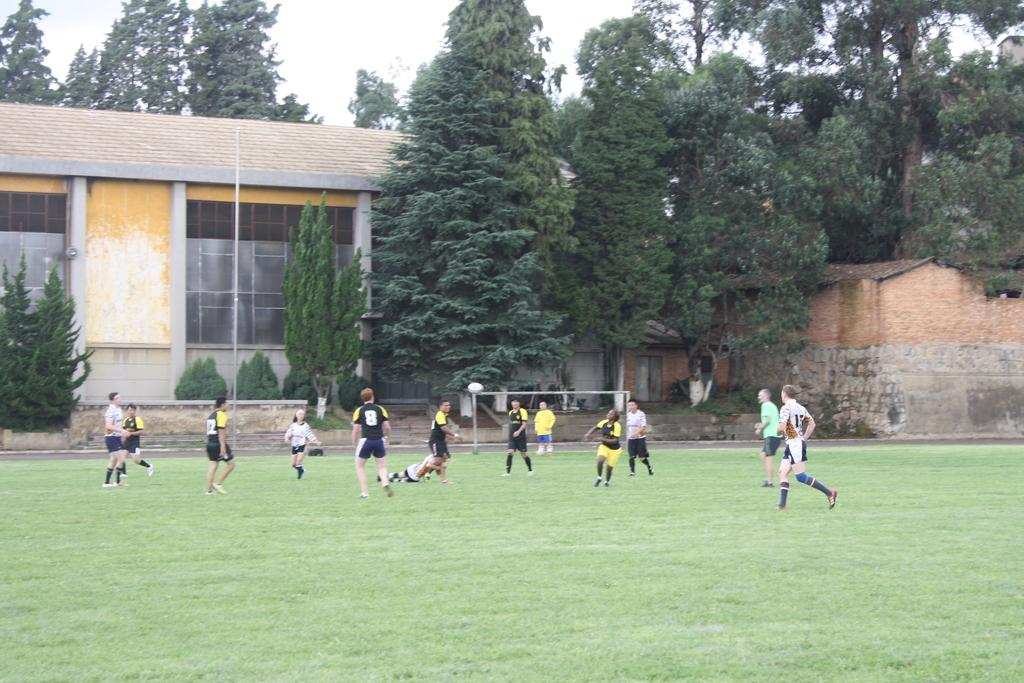What is the setting of the image? The image has an outside view. Who or what can be seen in the foreground? There are persons in the foreground. What are the persons wearing? The persons are wearing clothes. What activity are the persons engaged in? The persons are playing football. What can be seen in the background of the image? There is a building and trees in the background. What type of industry can be seen in the image? There is no industry present in the image; it features an outdoor scene with persons playing football. What kind of care is being provided to the flesh in the image? There is no reference to any care being provided to flesh in the image; it focuses on persons playing football outdoors. 